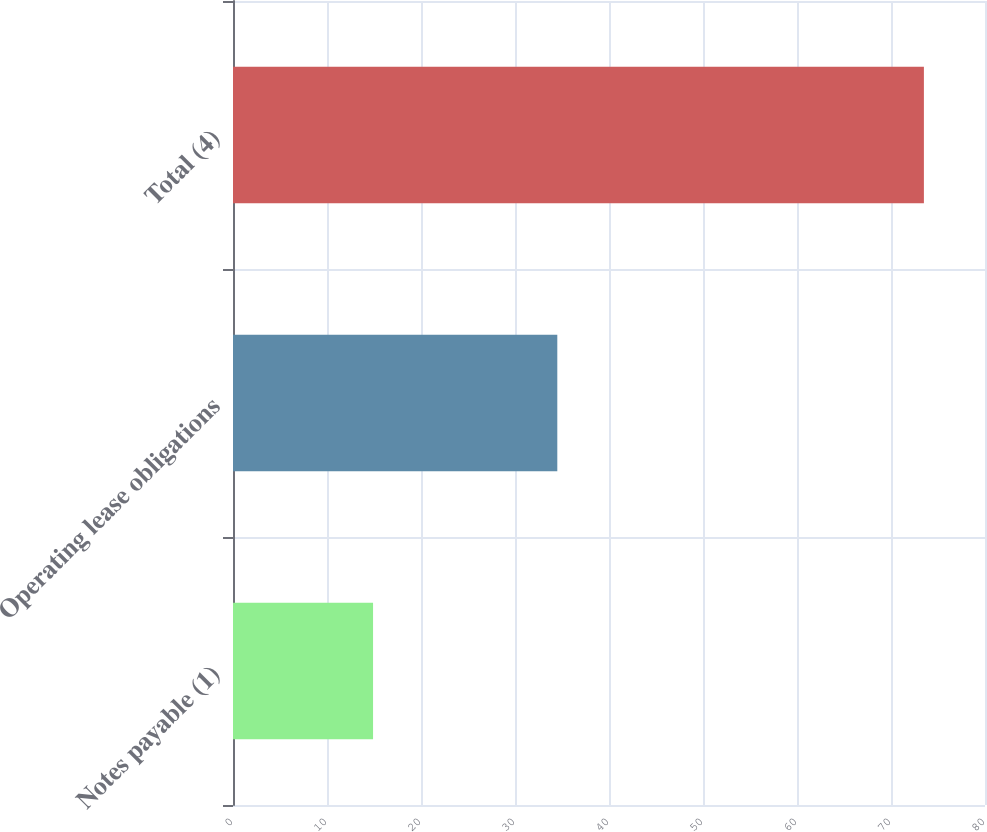Convert chart. <chart><loc_0><loc_0><loc_500><loc_500><bar_chart><fcel>Notes payable (1)<fcel>Operating lease obligations<fcel>Total (4)<nl><fcel>14.9<fcel>34.5<fcel>73.5<nl></chart> 